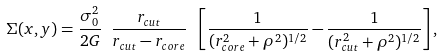<formula> <loc_0><loc_0><loc_500><loc_500>\Sigma ( x , y ) = \frac { \sigma _ { 0 } ^ { 2 } } { 2 G } \ \frac { r _ { c u t } } { r _ { c u t } - r _ { c o r e } } \ \left [ \frac { 1 } { ( r _ { c o r e } ^ { 2 } + \rho ^ { 2 } ) ^ { 1 / 2 } } - \frac { 1 } { ( r _ { c u t } ^ { 2 } + \rho ^ { 2 } ) ^ { 1 / 2 } } \right ] ,</formula> 